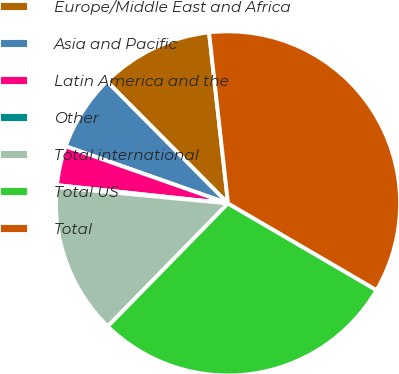Convert chart to OTSL. <chart><loc_0><loc_0><loc_500><loc_500><pie_chart><fcel>Europe/Middle East and Africa<fcel>Asia and Pacific<fcel>Latin America and the<fcel>Other<fcel>Total international<fcel>Total US<fcel>Total<nl><fcel>10.68%<fcel>7.18%<fcel>3.69%<fcel>0.19%<fcel>14.18%<fcel>28.91%<fcel>35.17%<nl></chart> 